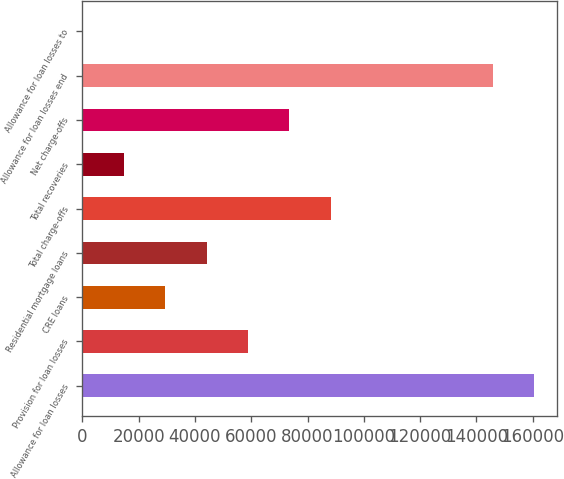<chart> <loc_0><loc_0><loc_500><loc_500><bar_chart><fcel>Allowance for loan losses<fcel>Provision for loan losses<fcel>CRE loans<fcel>Residential mortgage loans<fcel>Total charge-offs<fcel>Total recoveries<fcel>Net charge-offs<fcel>Allowance for loan losses end<fcel>Allowance for loan losses to<nl><fcel>160452<fcel>58834.9<fcel>29418.5<fcel>44126.7<fcel>88251.3<fcel>14710.4<fcel>73543.1<fcel>145744<fcel>2.18<nl></chart> 